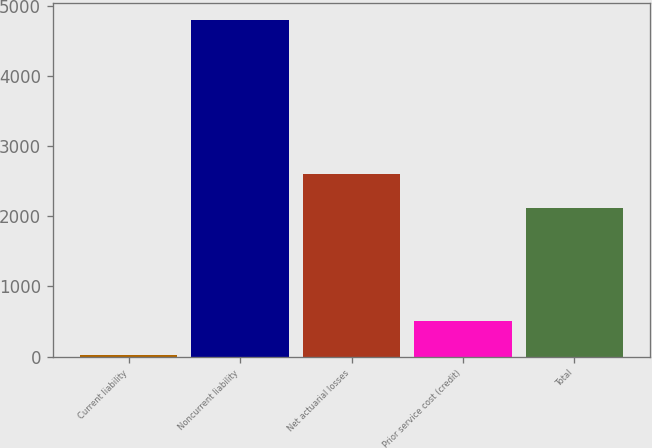Convert chart. <chart><loc_0><loc_0><loc_500><loc_500><bar_chart><fcel>Current liability<fcel>Noncurrent liability<fcel>Net actuarial losses<fcel>Prior service cost (credit)<fcel>Total<nl><fcel>27<fcel>4803<fcel>2603.6<fcel>504.6<fcel>2126<nl></chart> 